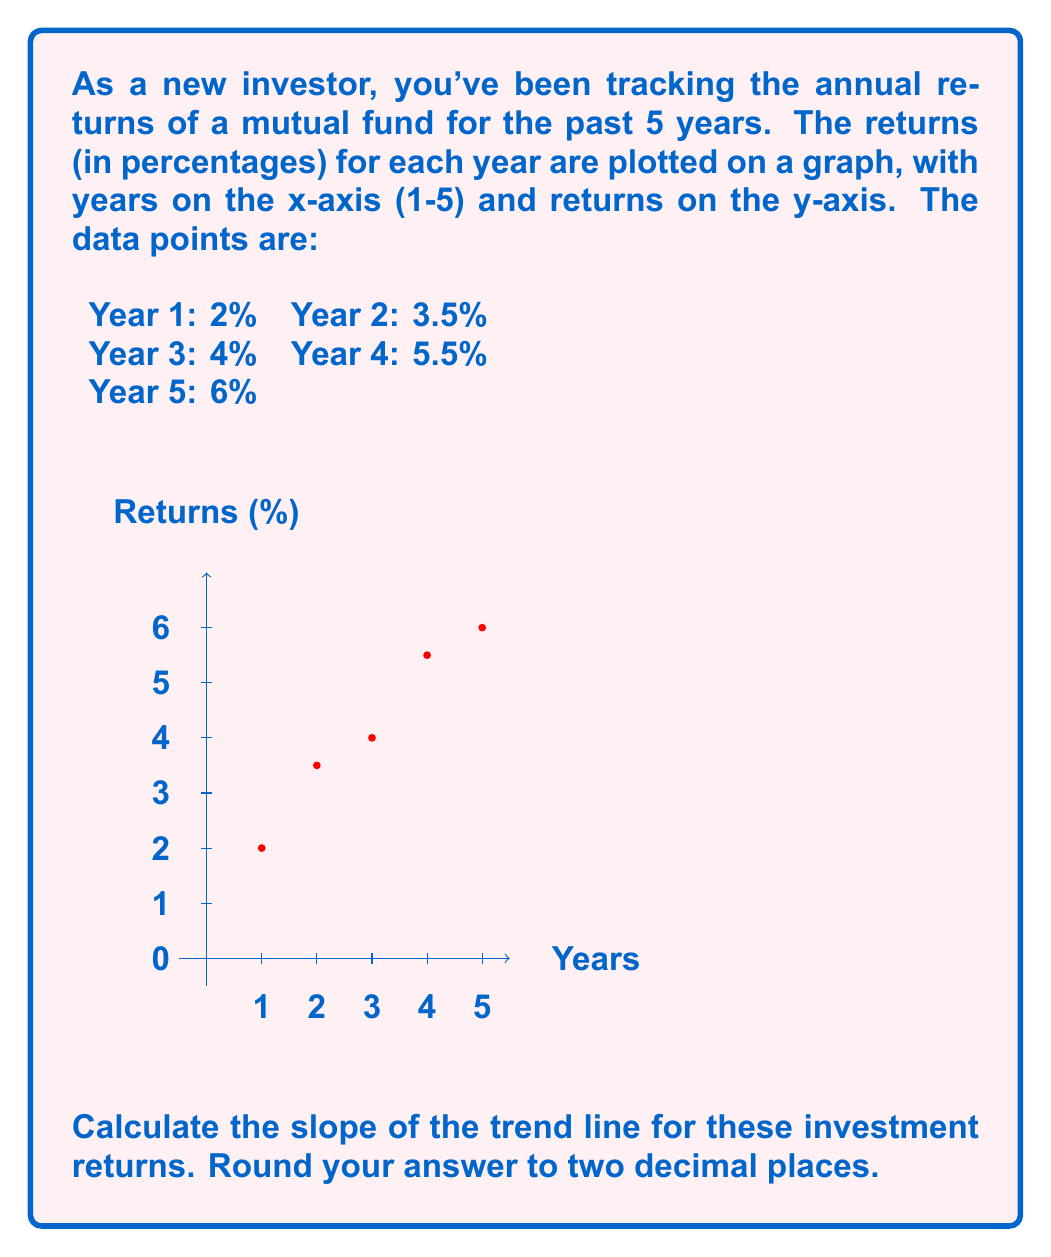Provide a solution to this math problem. To calculate the slope of the trend line, we'll use the formula:

$$ m = \frac{\sum_{i=1}^n (x_i - \bar{x})(y_i - \bar{y})}{\sum_{i=1}^n (x_i - \bar{x})^2} $$

Where:
$m$ is the slope
$x_i$ are the x-values (years)
$y_i$ are the y-values (returns)
$\bar{x}$ is the mean of x-values
$\bar{y}$ is the mean of y-values
$n$ is the number of data points

Step 1: Calculate $\bar{x}$ and $\bar{y}$
$\bar{x} = \frac{1 + 2 + 3 + 4 + 5}{5} = 3$
$\bar{y} = \frac{2 + 3.5 + 4 + 5.5 + 6}{5} = 4.2$

Step 2: Calculate $(x_i - \bar{x})$ and $(y_i - \bar{y})$ for each point:
1. $(-2, -2.2)$
2. $(-1, -0.7)$
3. $(0, -0.2)$
4. $(1, 1.3)$
5. $(2, 1.8)$

Step 3: Calculate $(x_i - \bar{x})(y_i - \bar{y})$ and $(x_i - \bar{x})^2$ for each point:
1. $4.4$ and $4$
2. $0.7$ and $1$
3. $0$ and $0$
4. $1.3$ and $1$
5. $3.6$ and $4$

Step 4: Sum the values:
$\sum (x_i - \bar{x})(y_i - \bar{y}) = 10$
$\sum (x_i - \bar{x})^2 = 10$

Step 5: Apply the formula:
$$ m = \frac{10}{10} = 1 $$

Therefore, the slope of the trend line is 1, or 1% per year when considering the units.
Answer: 1.00 